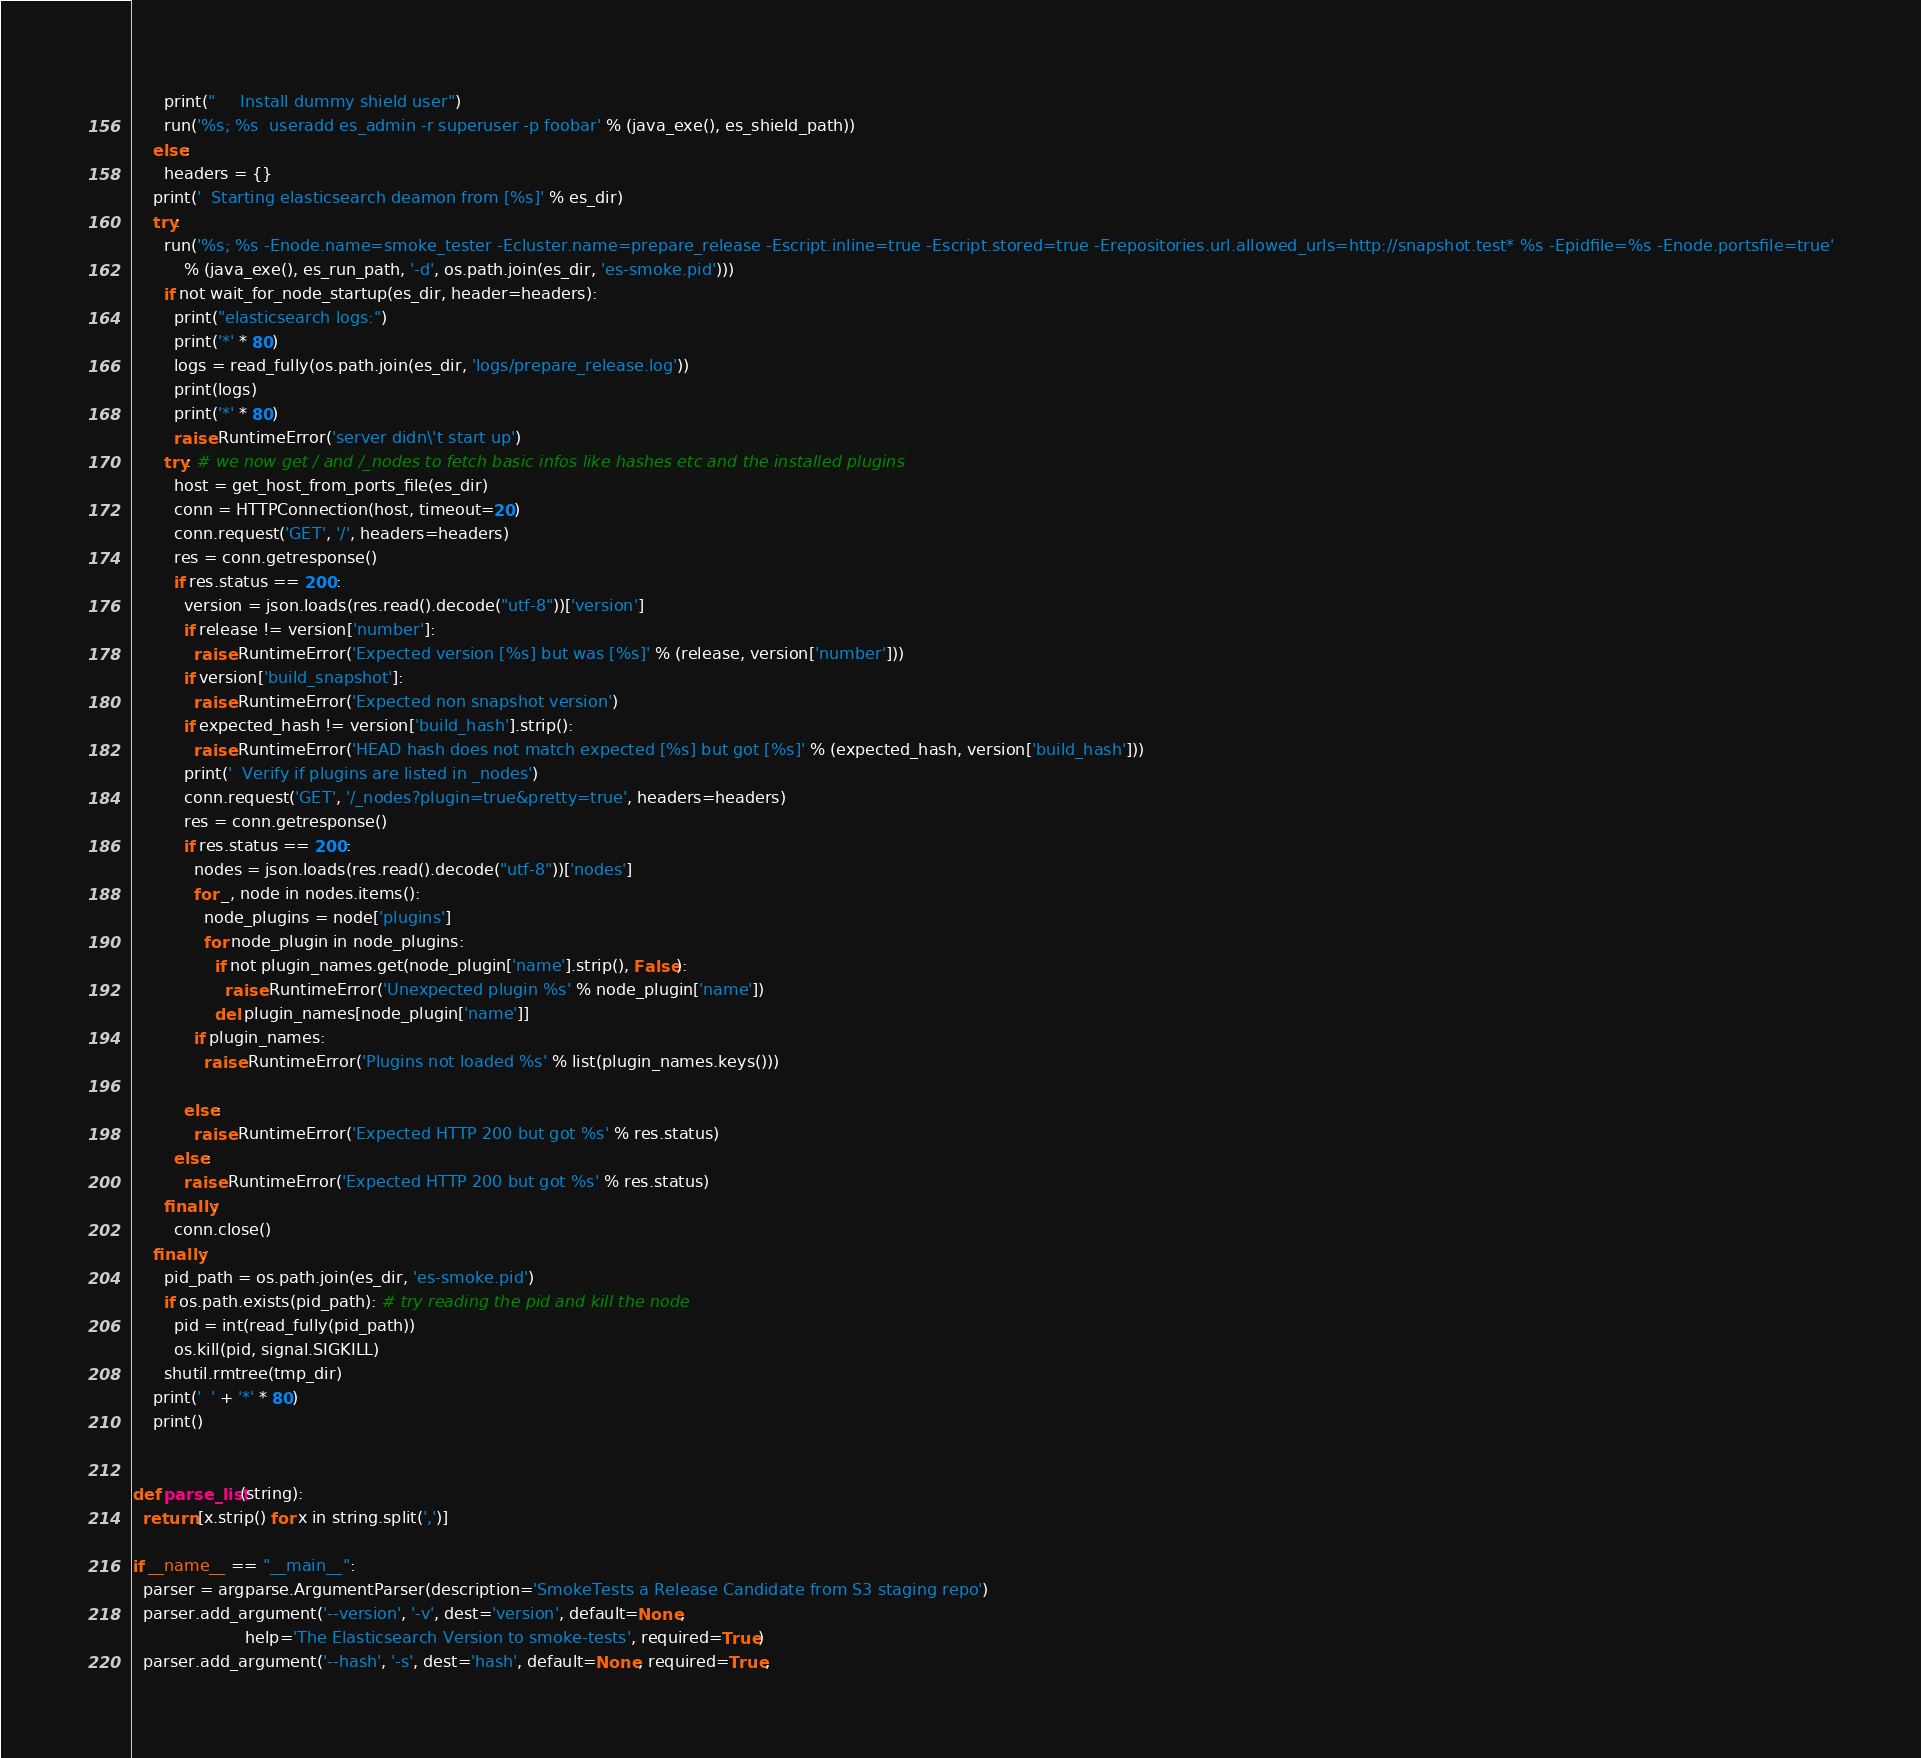<code> <loc_0><loc_0><loc_500><loc_500><_Python_>      print("     Install dummy shield user")
      run('%s; %s  useradd es_admin -r superuser -p foobar' % (java_exe(), es_shield_path))
    else:
      headers = {}
    print('  Starting elasticsearch deamon from [%s]' % es_dir)
    try:
      run('%s; %s -Enode.name=smoke_tester -Ecluster.name=prepare_release -Escript.inline=true -Escript.stored=true -Erepositories.url.allowed_urls=http://snapshot.test* %s -Epidfile=%s -Enode.portsfile=true'
          % (java_exe(), es_run_path, '-d', os.path.join(es_dir, 'es-smoke.pid')))
      if not wait_for_node_startup(es_dir, header=headers):
        print("elasticsearch logs:")
        print('*' * 80)
        logs = read_fully(os.path.join(es_dir, 'logs/prepare_release.log'))
        print(logs)
        print('*' * 80)
        raise RuntimeError('server didn\'t start up')
      try: # we now get / and /_nodes to fetch basic infos like hashes etc and the installed plugins
        host = get_host_from_ports_file(es_dir)
        conn = HTTPConnection(host, timeout=20)
        conn.request('GET', '/', headers=headers)
        res = conn.getresponse()
        if res.status == 200:
          version = json.loads(res.read().decode("utf-8"))['version']
          if release != version['number']:
            raise RuntimeError('Expected version [%s] but was [%s]' % (release, version['number']))
          if version['build_snapshot']:
            raise RuntimeError('Expected non snapshot version')
          if expected_hash != version['build_hash'].strip():
            raise RuntimeError('HEAD hash does not match expected [%s] but got [%s]' % (expected_hash, version['build_hash']))
          print('  Verify if plugins are listed in _nodes')
          conn.request('GET', '/_nodes?plugin=true&pretty=true', headers=headers)
          res = conn.getresponse()
          if res.status == 200:
            nodes = json.loads(res.read().decode("utf-8"))['nodes']
            for _, node in nodes.items():
              node_plugins = node['plugins']
              for node_plugin in node_plugins:
                if not plugin_names.get(node_plugin['name'].strip(), False):
                  raise RuntimeError('Unexpected plugin %s' % node_plugin['name'])
                del plugin_names[node_plugin['name']]
            if plugin_names:
              raise RuntimeError('Plugins not loaded %s' % list(plugin_names.keys()))

          else:
            raise RuntimeError('Expected HTTP 200 but got %s' % res.status)
        else:
          raise RuntimeError('Expected HTTP 200 but got %s' % res.status)
      finally:
        conn.close()
    finally:
      pid_path = os.path.join(es_dir, 'es-smoke.pid')
      if os.path.exists(pid_path): # try reading the pid and kill the node
        pid = int(read_fully(pid_path))
        os.kill(pid, signal.SIGKILL)
      shutil.rmtree(tmp_dir)
    print('  ' + '*' * 80)
    print()


def parse_list(string):
  return [x.strip() for x in string.split(',')]

if __name__ == "__main__":
  parser = argparse.ArgumentParser(description='SmokeTests a Release Candidate from S3 staging repo')
  parser.add_argument('--version', '-v', dest='version', default=None,
                      help='The Elasticsearch Version to smoke-tests', required=True)
  parser.add_argument('--hash', '-s', dest='hash', default=None, required=True,</code> 